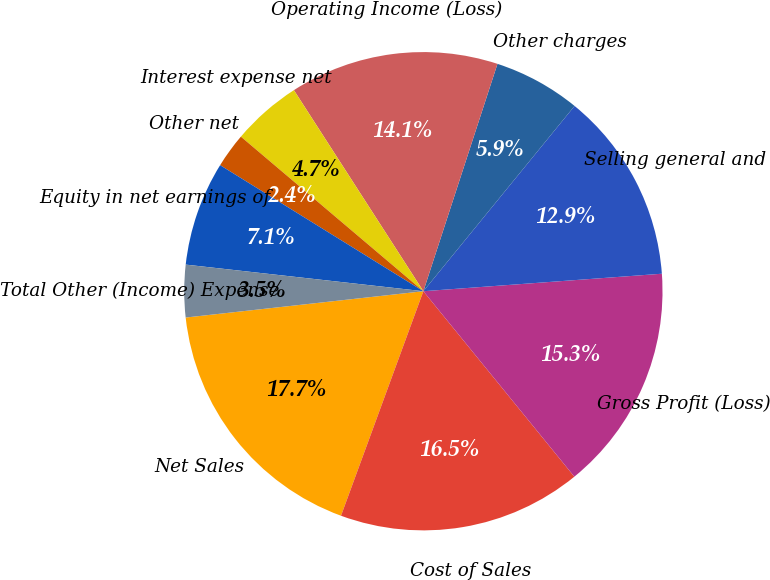Convert chart to OTSL. <chart><loc_0><loc_0><loc_500><loc_500><pie_chart><fcel>Net Sales<fcel>Cost of Sales<fcel>Gross Profit (Loss)<fcel>Selling general and<fcel>Other charges<fcel>Operating Income (Loss)<fcel>Interest expense net<fcel>Other net<fcel>Equity in net earnings of<fcel>Total Other (Income) Expense<nl><fcel>17.65%<fcel>16.47%<fcel>15.29%<fcel>12.94%<fcel>5.88%<fcel>14.12%<fcel>4.71%<fcel>2.35%<fcel>7.06%<fcel>3.53%<nl></chart> 